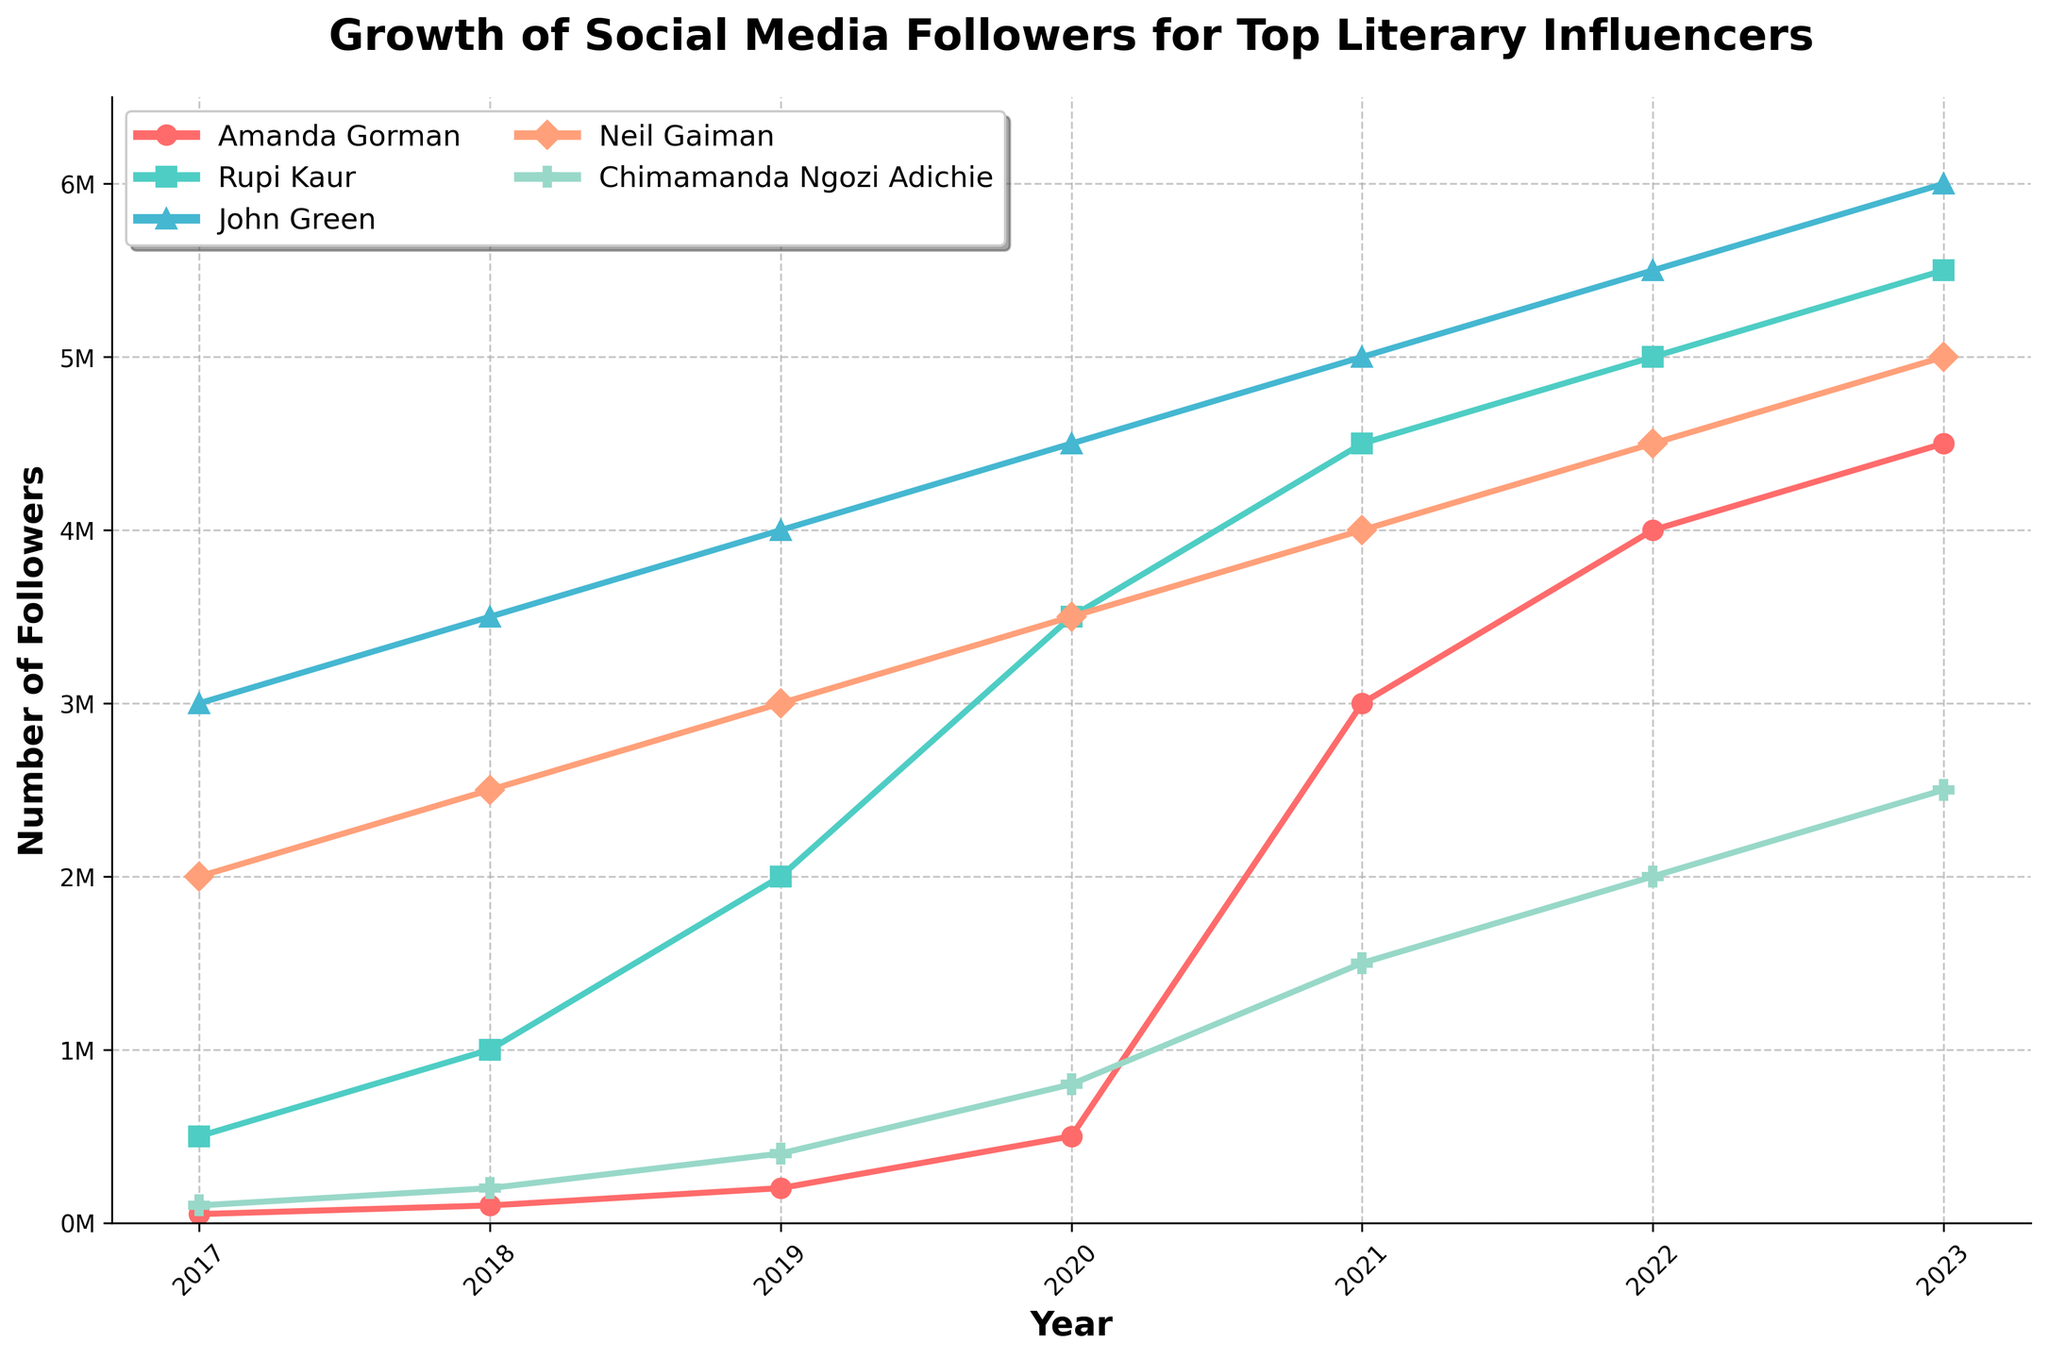What is the numerical difference in the number of followers between Neil Gaiman and Chimamanda Ngozi Adichie in 2023? In 2023, the number of followers for Neil Gaiman is 5,000,000 and for Chimamanda Ngozi Adichie is 2,500,000. The difference is calculated as 5,000,000 - 2,500,000 = 2,500,000.
Answer: 2,500,000 Which influencer saw the most significant increase in followers between 2020 and 2021? From 2020 to 2021, we can see that Amanda Gorman had an increase from 500,000 to 3,000,000, which is a jump of 2,500,000 followers. For others, the increases are less than 2,500,000.
Answer: Amanda Gorman What year did Rupi Kaur surpass 4,000,000 followers? By looking at the data points for Rupi Kaur, it is clear that in 2019 she had 2,000,000 followers, and in 2020, she had 3,500,000. It is only in 2021 that her followers reached 4,500,000, so she surpassed 4,000,000 in 2021.
Answer: 2021 Whose number of followers remained below 1,000,000 until 2020? By looking at the data for each influencer, we see that Amanda Gorman had fewer than 1,000,000 followers until 2020 when she reached 500,000 followers. All other influencers had over 1,000,000 followers before 2020.
Answer: Amanda Gorman What is the combined total number of followers for all influencers in 2022? In 2022, the followers for each influencer are: Amanda Gorman (4,000,000), Rupi Kaur (5,000,000), John Green (5,500,000), Neil Gaiman (4,500,000), Chimamanda Ngozi Adichie (2,000,000). Summing these up: 4,000,000 + 5,000,000 + 5,500,000 + 4,500,000 + 2,000,000 = 21,000,000.
Answer: 21,000,000 Which influencer had the smallest growth in followers from 2021 to 2023? By referring to the details from 2021 to 2023: Amanda Gorman (1,000,000 growth), Rupi Kaur (1,000,000 growth), John Green (1,000,000 growth), Neil Gaiman (1,000,000 growth), and Chimamanda Ngozi Adichie (750,000 growth). Chimamanda Ngozi Adichie had the smallest growth.
Answer: Chimamanda Ngozi Adichie In 2019, how many more followers did John Green have compared to Neil Gaiman? In 2019, John Green had 4,000,000 followers and Neil Gaiman had 3,000,000 followers. The difference is 4,000,000 - 3,000,000 = 1,000,000.
Answer: 1,000,000 Which influencer had the highest number of followers in 2020, and what was the number? By examining the 2020 data points, John Green had the highest number of followers, which was 4,500,000.
Answer: John Green, 4,500,000 